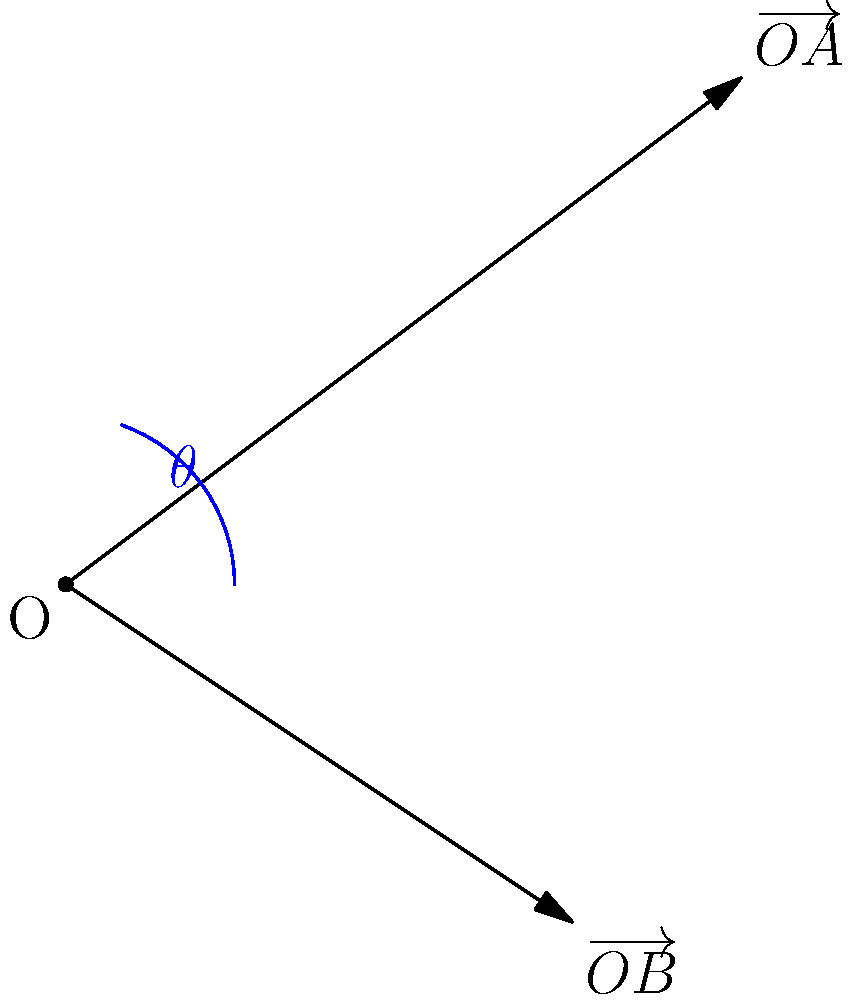Two intercepted Soviet radio signals are represented by vectors $\overrightarrow{OA}(4,3)$ and $\overrightarrow{OB}(3,-2)$ in a coordinate system. Calculate the angle $\theta$ between these two vectors, which could indicate the relative positions of two Soviet transmitters. To find the angle between two vectors, we can use the dot product formula:

$$\cos \theta = \frac{\overrightarrow{OA} \cdot \overrightarrow{OB}}{|\overrightarrow{OA}| |\overrightarrow{OB}|}$$

Step 1: Calculate the dot product $\overrightarrow{OA} \cdot \overrightarrow{OB}$
$\overrightarrow{OA} \cdot \overrightarrow{OB} = (4)(3) + (3)(-2) = 12 - 6 = 6$

Step 2: Calculate the magnitudes of the vectors
$|\overrightarrow{OA}| = \sqrt{4^2 + 3^2} = \sqrt{25} = 5$
$|\overrightarrow{OB}| = \sqrt{3^2 + (-2)^2} = \sqrt{13}$

Step 3: Apply the formula
$$\cos \theta = \frac{6}{5\sqrt{13}}$$

Step 4: Take the inverse cosine (arccos) of both sides
$$\theta = \arccos(\frac{6}{5\sqrt{13}})$$

Step 5: Calculate the final result
$$\theta \approx 74.5^\circ$$

This angle represents the direction difference between the two intercepted signals, which could be crucial for triangulating the positions of Soviet transmitters.
Answer: $74.5^\circ$ 